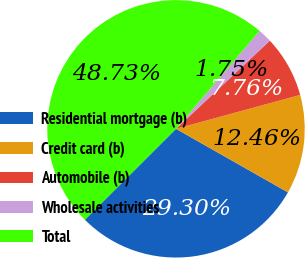Convert chart. <chart><loc_0><loc_0><loc_500><loc_500><pie_chart><fcel>Residential mortgage (b)<fcel>Credit card (b)<fcel>Automobile (b)<fcel>Wholesale activities<fcel>Total<nl><fcel>29.3%<fcel>12.46%<fcel>7.76%<fcel>1.75%<fcel>48.73%<nl></chart> 